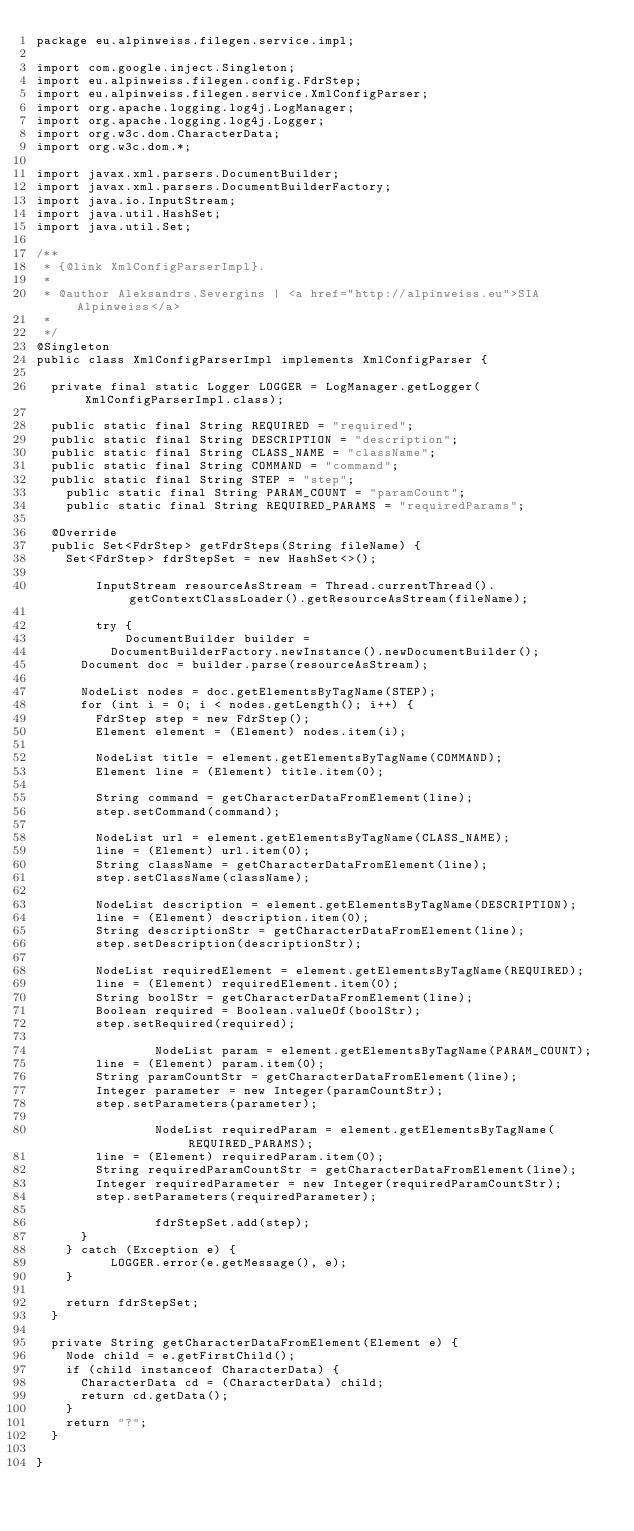Convert code to text. <code><loc_0><loc_0><loc_500><loc_500><_Java_>package eu.alpinweiss.filegen.service.impl;

import com.google.inject.Singleton;
import eu.alpinweiss.filegen.config.FdrStep;
import eu.alpinweiss.filegen.service.XmlConfigParser;
import org.apache.logging.log4j.LogManager;
import org.apache.logging.log4j.Logger;
import org.w3c.dom.CharacterData;
import org.w3c.dom.*;

import javax.xml.parsers.DocumentBuilder;
import javax.xml.parsers.DocumentBuilderFactory;
import java.io.InputStream;
import java.util.HashSet;
import java.util.Set;

/**
 * {@link XmlConfigParserImpl}.
 * 
 * @author Aleksandrs.Severgins | <a href="http://alpinweiss.eu">SIA Alpinweiss</a>
 *
 */
@Singleton
public class XmlConfigParserImpl implements XmlConfigParser {

	private final static Logger LOGGER = LogManager.getLogger(XmlConfigParserImpl.class);

	public static final String REQUIRED = "required";
	public static final String DESCRIPTION = "description";
	public static final String CLASS_NAME = "className";
	public static final String COMMAND = "command";
	public static final String STEP = "step";
    public static final String PARAM_COUNT = "paramCount";
    public static final String REQUIRED_PARAMS = "requiredParams";

	@Override
	public Set<FdrStep> getFdrSteps(String fileName) {
		Set<FdrStep> fdrStepSet = new HashSet<>();

        InputStream resourceAsStream = Thread.currentThread().getContextClassLoader().getResourceAsStream(fileName);

        try {
            DocumentBuilder builder =
					DocumentBuilderFactory.newInstance().newDocumentBuilder();
			Document doc = builder.parse(resourceAsStream);

			NodeList nodes = doc.getElementsByTagName(STEP);
			for (int i = 0; i < nodes.getLength(); i++) {
				FdrStep step = new FdrStep();
				Element element = (Element) nodes.item(i);

				NodeList title = element.getElementsByTagName(COMMAND);
				Element line = (Element) title.item(0);

				String command = getCharacterDataFromElement(line);
				step.setCommand(command);

				NodeList url = element.getElementsByTagName(CLASS_NAME);
				line = (Element) url.item(0);
				String className = getCharacterDataFromElement(line);
				step.setClassName(className);

				NodeList description = element.getElementsByTagName(DESCRIPTION);
				line = (Element) description.item(0);
				String descriptionStr = getCharacterDataFromElement(line);
				step.setDescription(descriptionStr);

				NodeList requiredElement = element.getElementsByTagName(REQUIRED);
				line = (Element) requiredElement.item(0);
				String boolStr = getCharacterDataFromElement(line);
				Boolean required = Boolean.valueOf(boolStr);
				step.setRequired(required);

                NodeList param = element.getElementsByTagName(PARAM_COUNT);
				line = (Element) param.item(0);
				String paramCountStr = getCharacterDataFromElement(line);
				Integer parameter = new Integer(paramCountStr);
				step.setParameters(parameter);

                NodeList requiredParam = element.getElementsByTagName(REQUIRED_PARAMS);
				line = (Element) requiredParam.item(0);
				String requiredParamCountStr = getCharacterDataFromElement(line);
				Integer requiredParameter = new Integer(requiredParamCountStr);
				step.setParameters(requiredParameter);

                fdrStepSet.add(step);
			}
		} catch (Exception e) {
	        LOGGER.error(e.getMessage(), e);
		}

		return fdrStepSet;
	}

	private String getCharacterDataFromElement(Element e) {
		Node child = e.getFirstChild();
		if (child instanceof CharacterData) {
			CharacterData cd = (CharacterData) child;
			return cd.getData();
		}
		return "?";
	}

}
</code> 